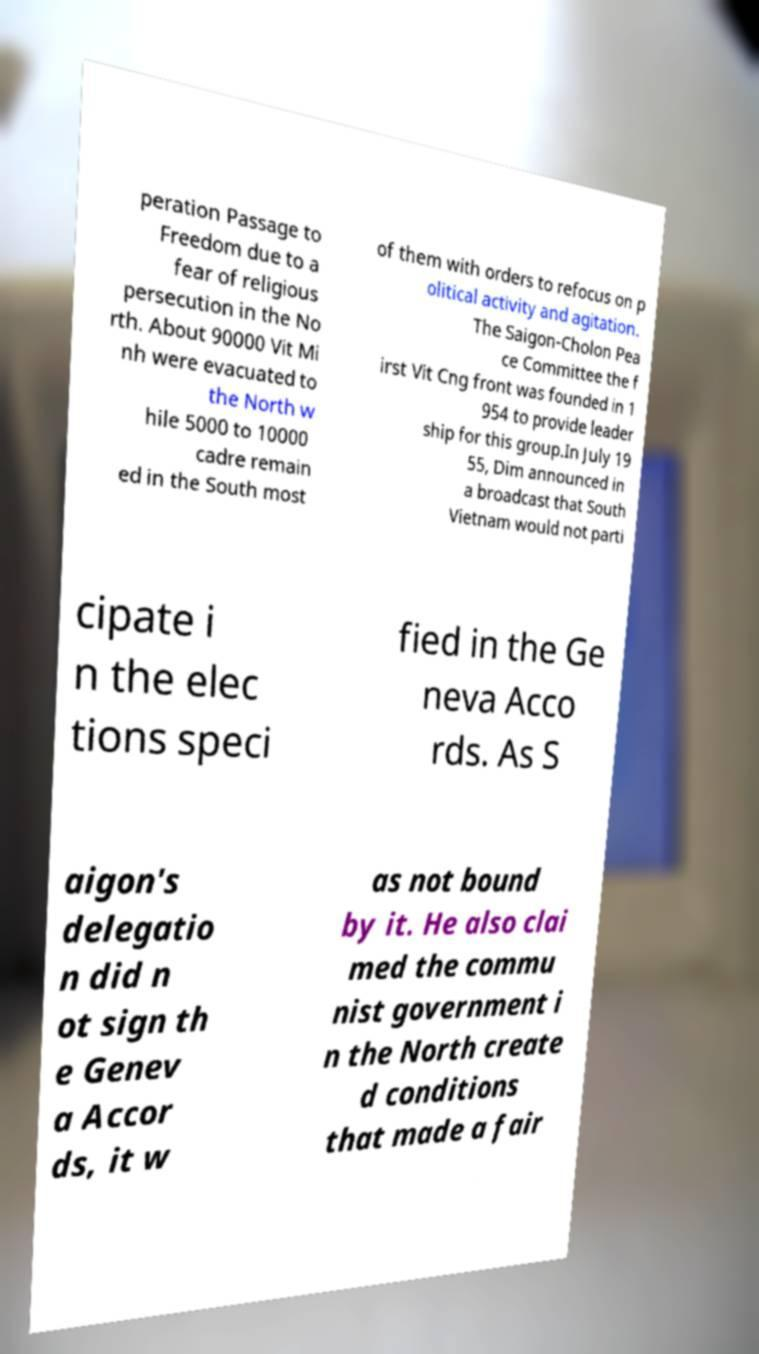What messages or text are displayed in this image? I need them in a readable, typed format. peration Passage to Freedom due to a fear of religious persecution in the No rth. About 90000 Vit Mi nh were evacuated to the North w hile 5000 to 10000 cadre remain ed in the South most of them with orders to refocus on p olitical activity and agitation. The Saigon-Cholon Pea ce Committee the f irst Vit Cng front was founded in 1 954 to provide leader ship for this group.In July 19 55, Dim announced in a broadcast that South Vietnam would not parti cipate i n the elec tions speci fied in the Ge neva Acco rds. As S aigon's delegatio n did n ot sign th e Genev a Accor ds, it w as not bound by it. He also clai med the commu nist government i n the North create d conditions that made a fair 